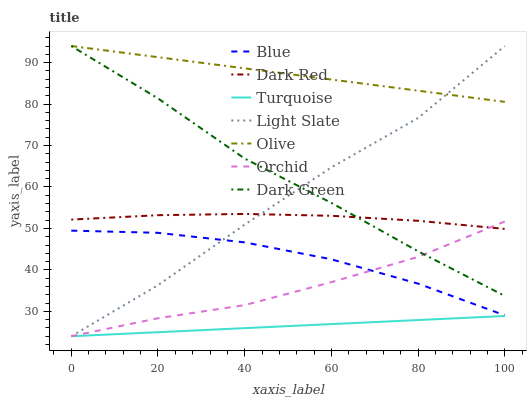Does Light Slate have the minimum area under the curve?
Answer yes or no. No. Does Light Slate have the maximum area under the curve?
Answer yes or no. No. Is Light Slate the smoothest?
Answer yes or no. No. Is Turquoise the roughest?
Answer yes or no. No. Does Dark Red have the lowest value?
Answer yes or no. No. Does Turquoise have the highest value?
Answer yes or no. No. Is Turquoise less than Blue?
Answer yes or no. Yes. Is Dark Red greater than Blue?
Answer yes or no. Yes. Does Turquoise intersect Blue?
Answer yes or no. No. 